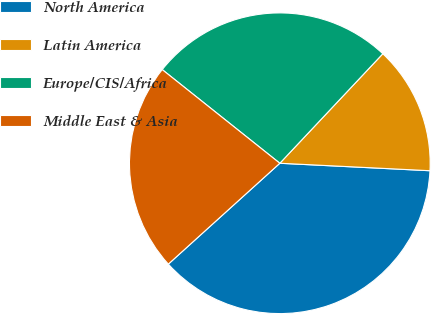<chart> <loc_0><loc_0><loc_500><loc_500><pie_chart><fcel>North America<fcel>Latin America<fcel>Europe/CIS/Africa<fcel>Middle East & Asia<nl><fcel>37.51%<fcel>13.78%<fcel>26.31%<fcel>22.41%<nl></chart> 